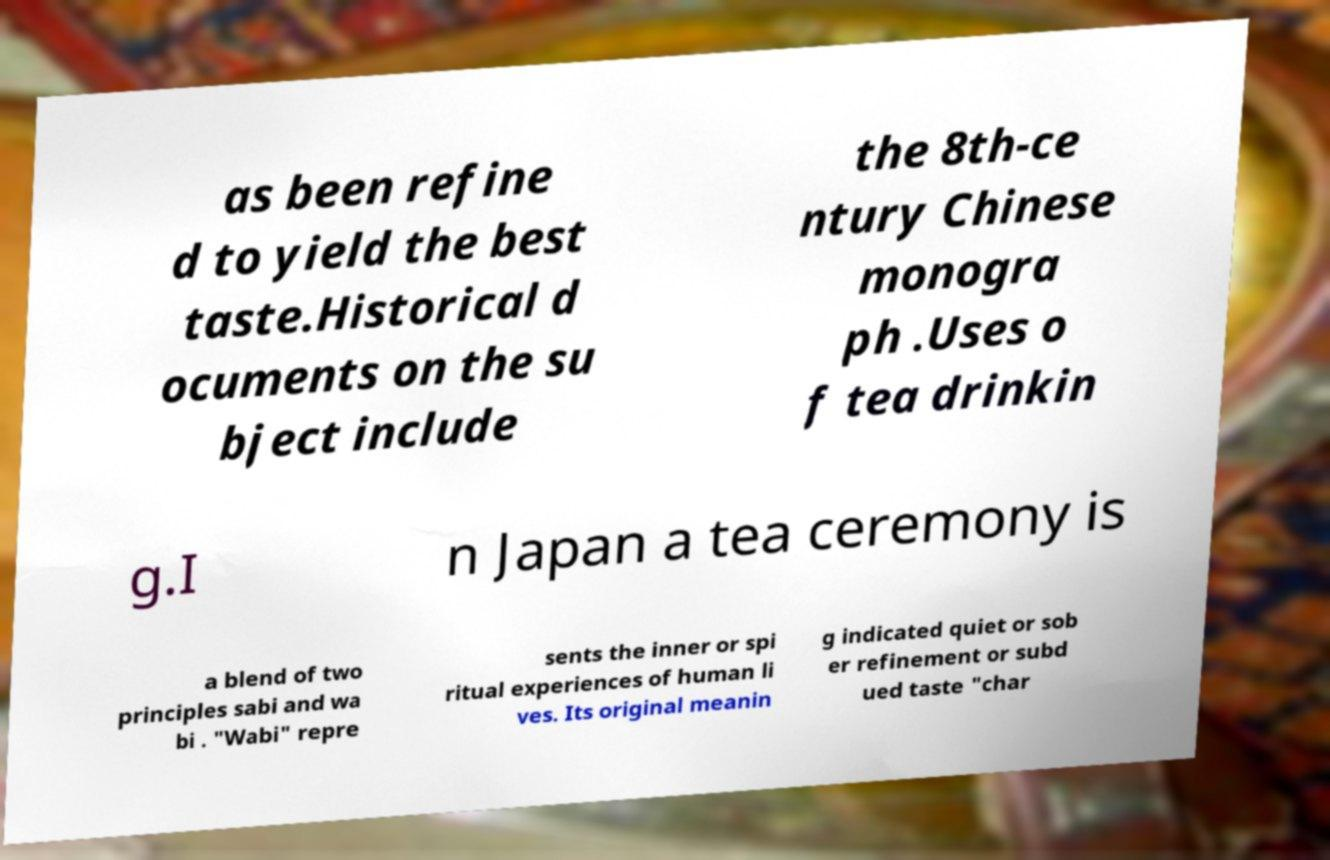Could you assist in decoding the text presented in this image and type it out clearly? as been refine d to yield the best taste.Historical d ocuments on the su bject include the 8th-ce ntury Chinese monogra ph .Uses o f tea drinkin g.I n Japan a tea ceremony is a blend of two principles sabi and wa bi . "Wabi" repre sents the inner or spi ritual experiences of human li ves. Its original meanin g indicated quiet or sob er refinement or subd ued taste "char 